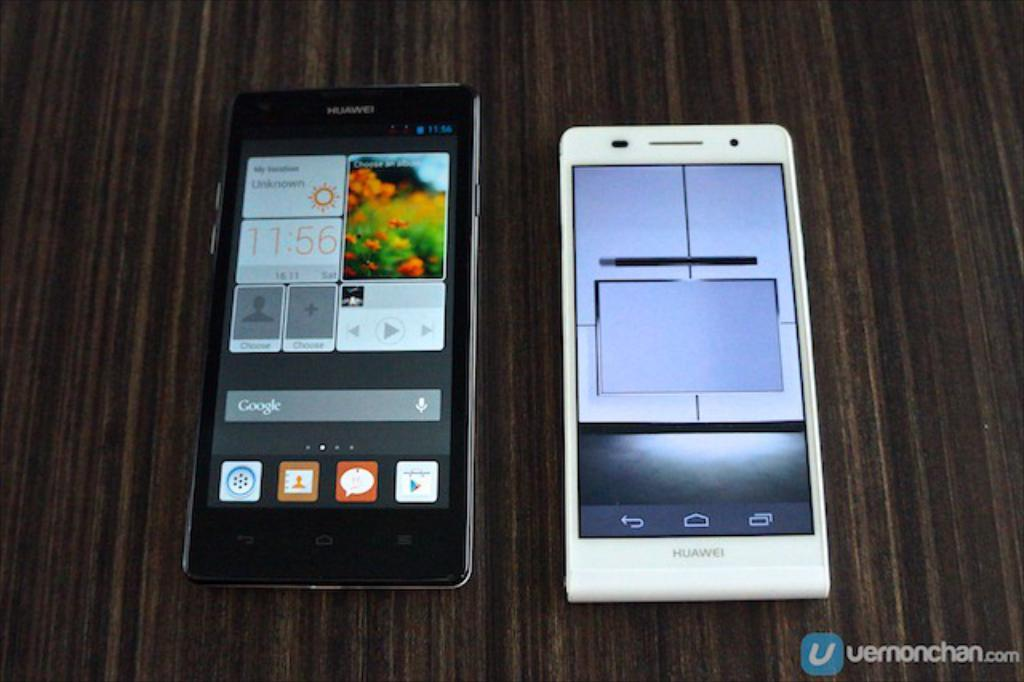Provide a one-sentence caption for the provided image. a white huawei phone next to a black huawei phone. 